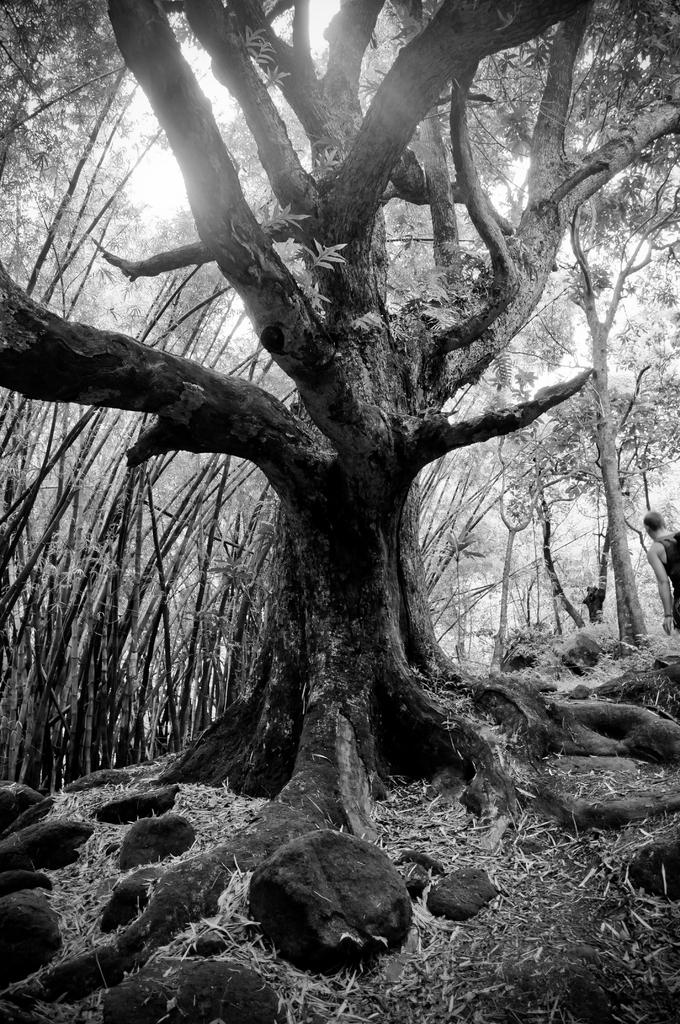What type of natural elements can be seen in the image? There are trees in the image. Can you describe the person in the image? There is a person standing in the image. What can be seen in the background of the image? The sky is visible in the background of the image. What is the color scheme of the image? The image is in black and white. How many parcels is the person holding in the image? There are no parcels visible in the image; the person is simply standing. What type of ticket can be seen in the image? There is no ticket present in the image. 